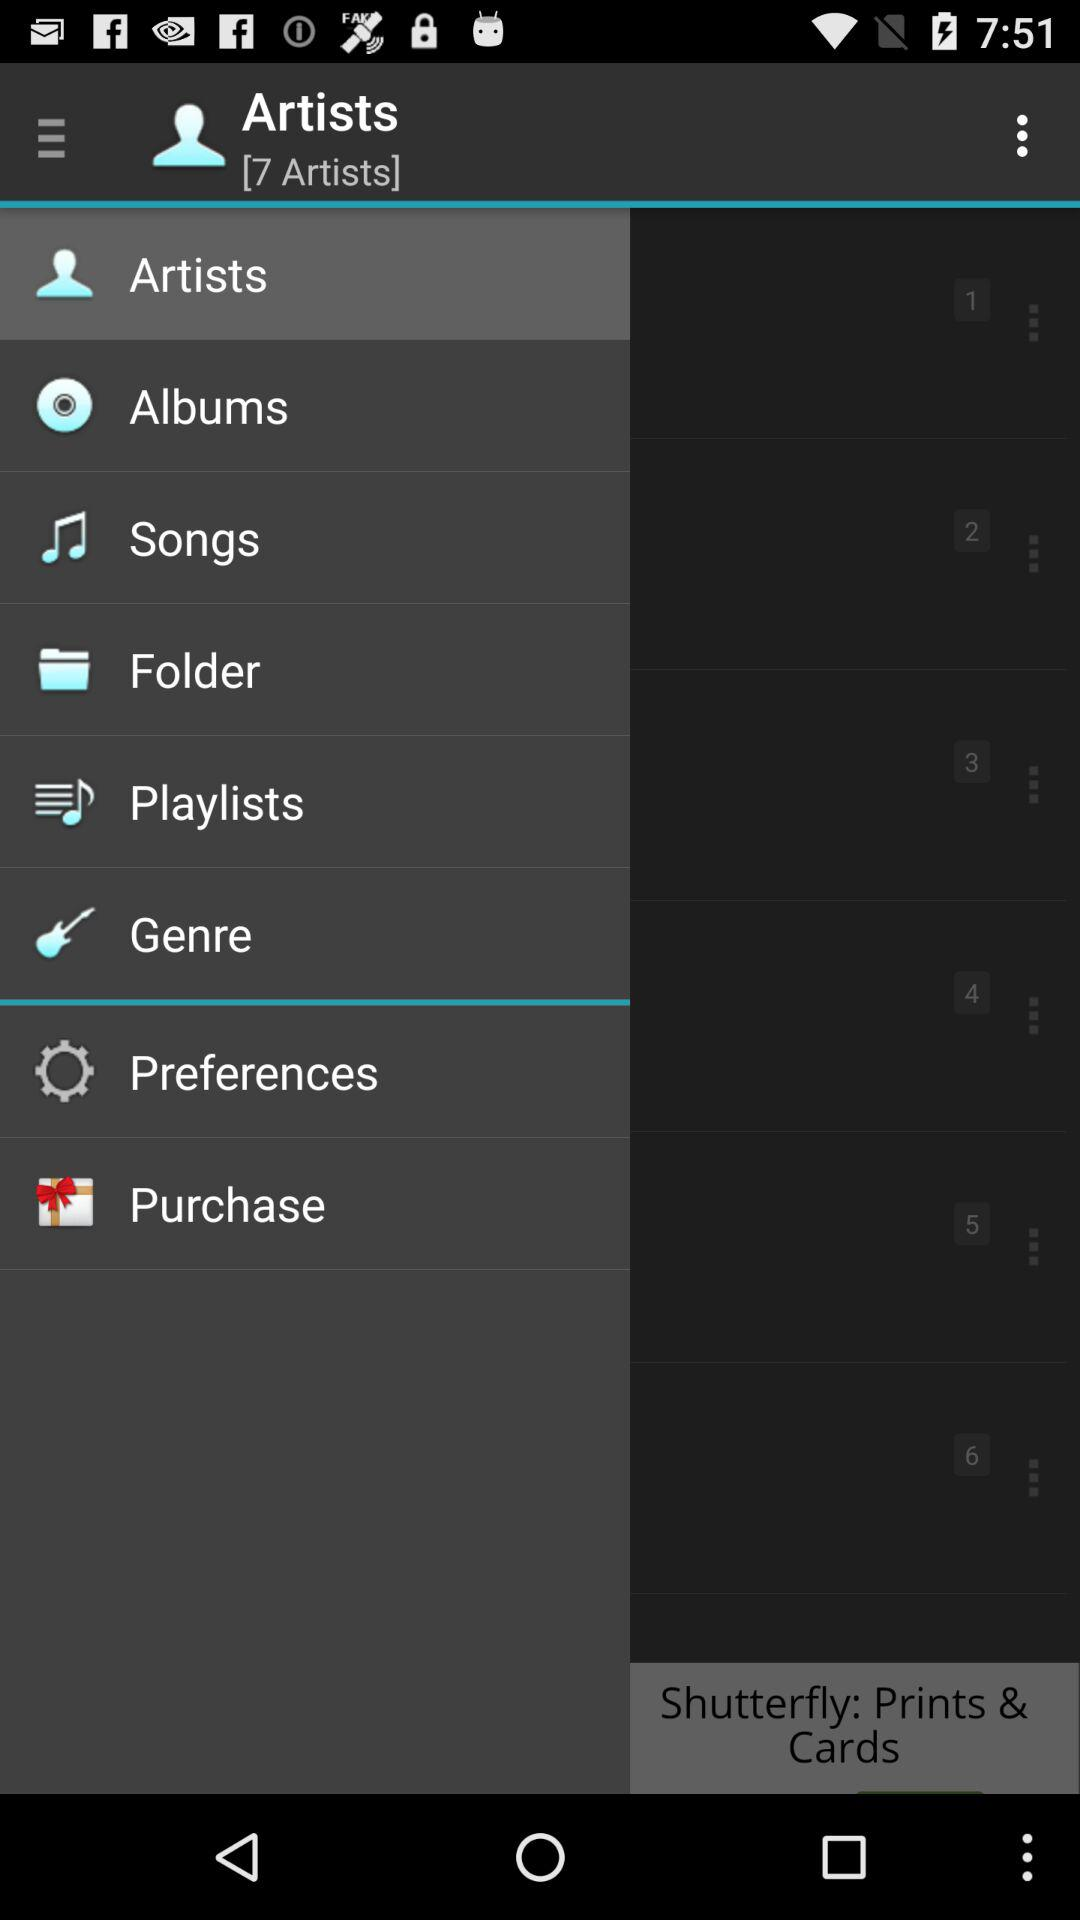What is the total number of artists given? The total number of artists given is 7. 